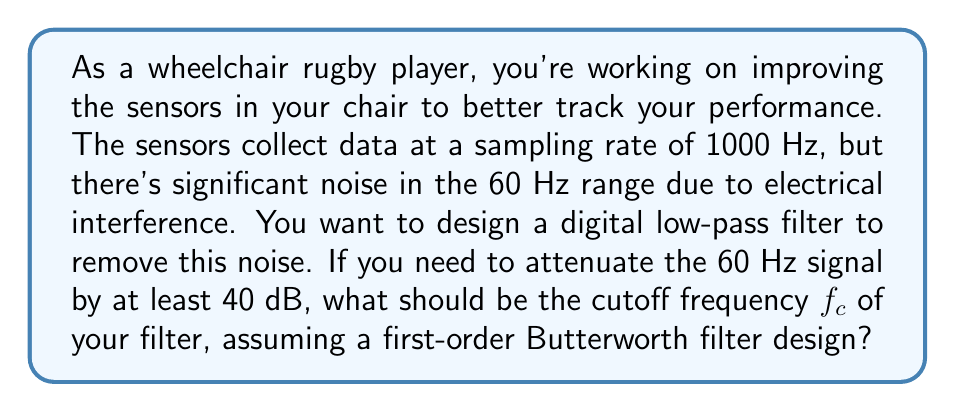What is the answer to this math problem? To solve this problem, we need to use the properties of a first-order Butterworth low-pass filter and the concept of decibel attenuation.

1) The magnitude response of a first-order Butterworth low-pass filter is given by:

   $$|H(f)| = \frac{1}{\sqrt{1 + (f/f_c)^2}}$$

   where $f$ is the frequency and $f_c$ is the cutoff frequency.

2) We need to attenuate the 60 Hz signal by at least 40 dB. The decibel attenuation is given by:

   $$\text{Attenuation (dB)} = -20 \log_{10}(|H(f)|)$$

3) Substituting our values:

   $$40 \leq -20 \log_{10}\left(\frac{1}{\sqrt{1 + (60/f_c)^2}}\right)$$

4) Simplifying:

   $$40 \leq 10 \log_{10}(1 + (60/f_c)^2)$$

5) Solving for $f_c$:

   $$10^4 \leq 1 + (60/f_c)^2$$
   $$10^4 - 1 \leq (60/f_c)^2$$
   $$\sqrt{10^4 - 1} \leq 60/f_c$$
   $$f_c \leq \frac{60}{\sqrt{10^4 - 1}} \approx 6.00 \text{ Hz}$$

6) Therefore, to attenuate the 60 Hz signal by at least 40 dB, the cutoff frequency should be no higher than approximately 6.00 Hz.
Answer: The cutoff frequency $f_c$ should be approximately 6.00 Hz or lower. 